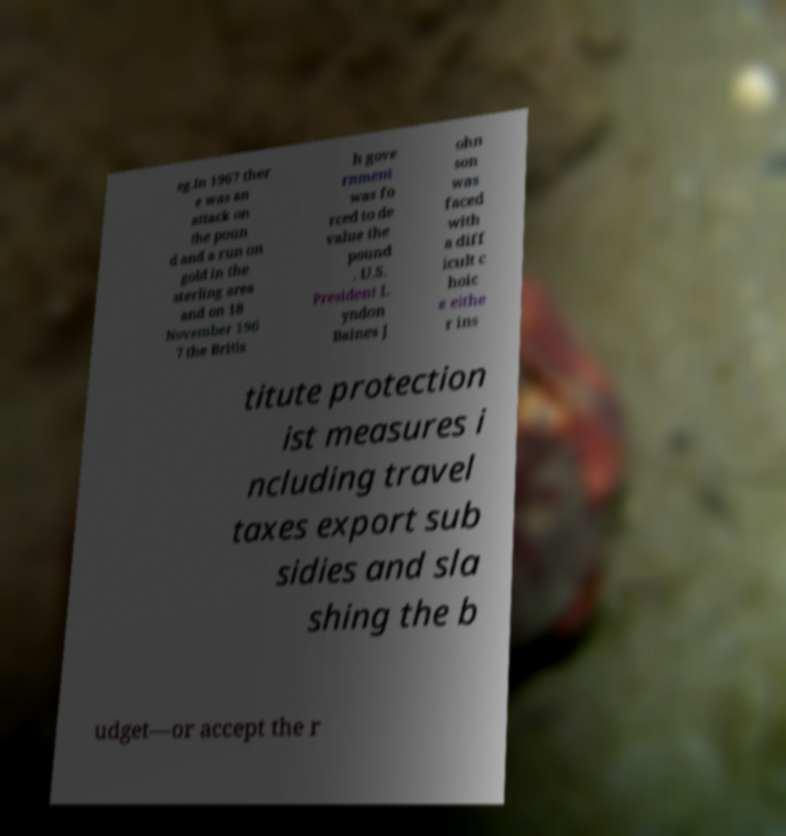Can you accurately transcribe the text from the provided image for me? eg.In 1967 ther e was an attack on the poun d and a run on gold in the sterling area and on 18 November 196 7 the Britis h gove rnment was fo rced to de value the pound . U.S. President L yndon Baines J ohn son was faced with a diff icult c hoic e eithe r ins titute protection ist measures i ncluding travel taxes export sub sidies and sla shing the b udget—or accept the r 